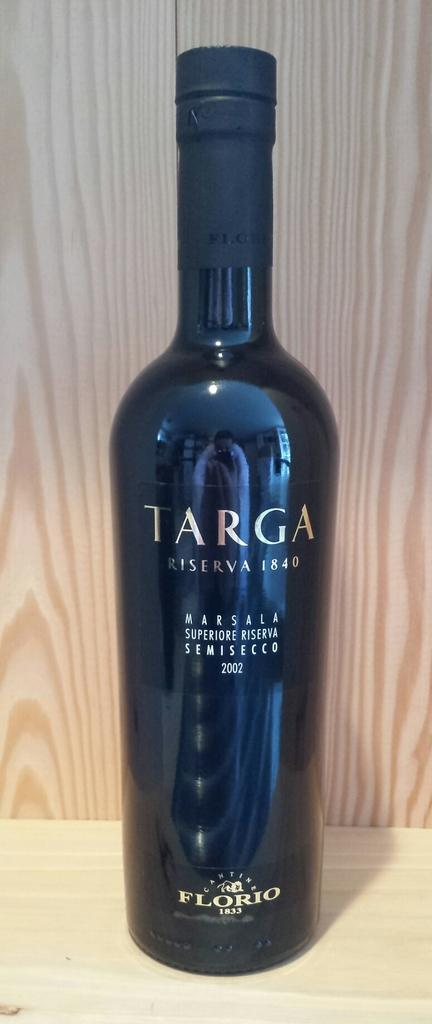<image>
Present a compact description of the photo's key features. Tall black bottle that says the word TARGA on top. 